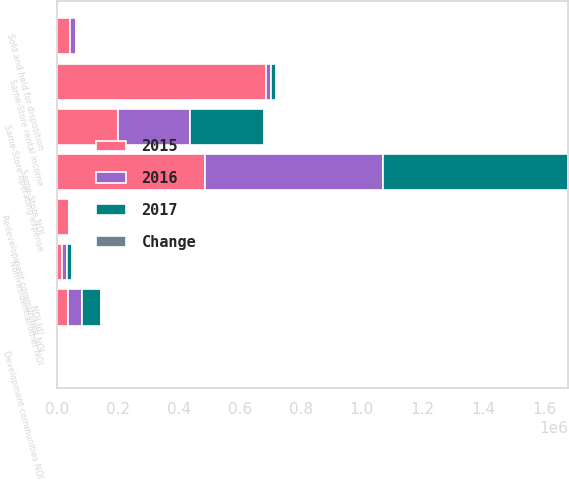<chart> <loc_0><loc_0><loc_500><loc_500><stacked_bar_chart><ecel><fcel>Same-Store rental income<fcel>Same-Store operating expense<fcel>Same-Store NOI<fcel>NOI (d)<fcel>Redevelopment communities NOI<fcel>Development communities NOI<fcel>Non-residential/other NOI<fcel>Sold and held for disposition<nl><fcel>2017<fcel>15955<fcel>242522<fcel>607543<fcel>61002<fcel>4021<fcel>295<fcel>17081<fcel>3368<nl><fcel>2016<fcel>15955<fcel>234385<fcel>585577<fcel>47711<fcel>4270<fcel>436<fcel>16244<fcel>19719<nl><fcel>Change<fcel>3.7<fcel>3.5<fcel>3.8<fcel>27.9<fcel>5.8<fcel>32.3<fcel>5.2<fcel>82.9<nl><fcel>2015<fcel>686589<fcel>200473<fcel>486116<fcel>33367<fcel>37682<fcel>114<fcel>15666<fcel>41152<nl></chart> 